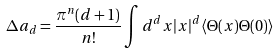<formula> <loc_0><loc_0><loc_500><loc_500>\Delta a _ { d } = \frac { \pi ^ { n } ( d + 1 ) } { n ! } \int d ^ { d } x | x | ^ { d } \langle \Theta ( x ) \Theta ( 0 ) \rangle</formula> 